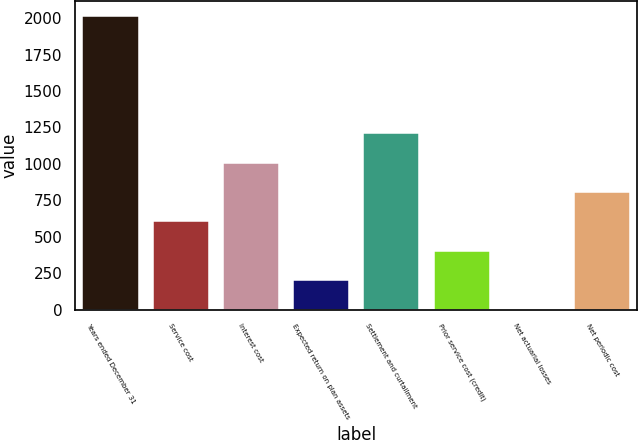<chart> <loc_0><loc_0><loc_500><loc_500><bar_chart><fcel>Years ended December 31<fcel>Service cost<fcel>Interest cost<fcel>Expected return on plan assets<fcel>Settlement and curtailment<fcel>Prior service cost (credit)<fcel>Net actuarial losses<fcel>Net periodic cost<nl><fcel>2018<fcel>605.47<fcel>1009.05<fcel>201.89<fcel>1210.84<fcel>403.68<fcel>0.1<fcel>807.26<nl></chart> 